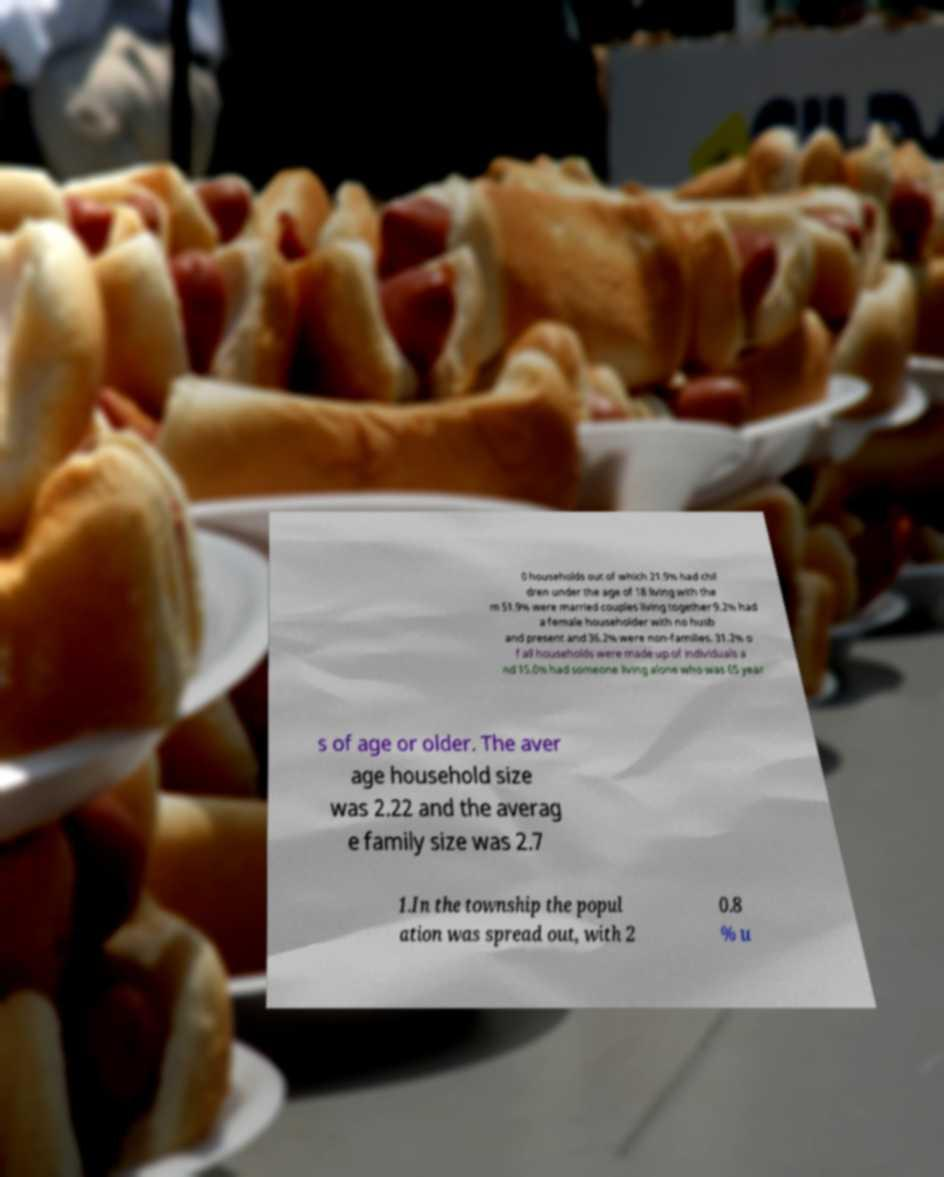Can you accurately transcribe the text from the provided image for me? 0 households out of which 21.9% had chil dren under the age of 18 living with the m 51.9% were married couples living together 9.2% had a female householder with no husb and present and 36.2% were non-families. 31.2% o f all households were made up of individuals a nd 15.0% had someone living alone who was 65 year s of age or older. The aver age household size was 2.22 and the averag e family size was 2.7 1.In the township the popul ation was spread out, with 2 0.8 % u 